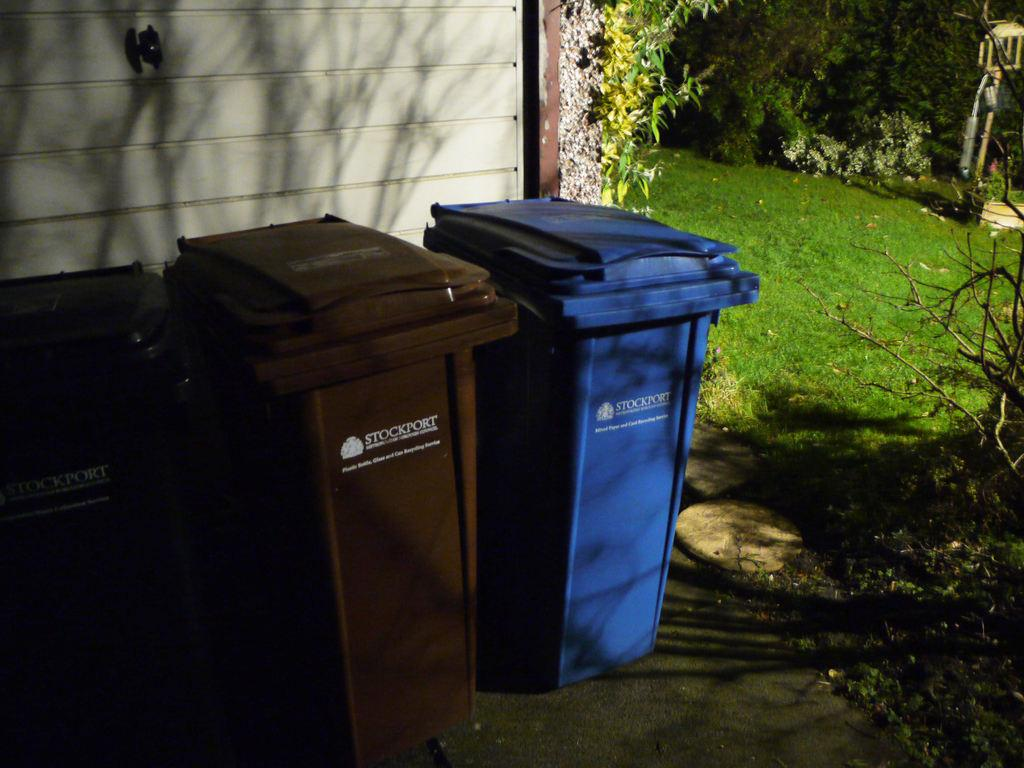<image>
Give a short and clear explanation of the subsequent image. Three Stockport bins, two brown and one blue, are sitting by the outside wall of a building. 